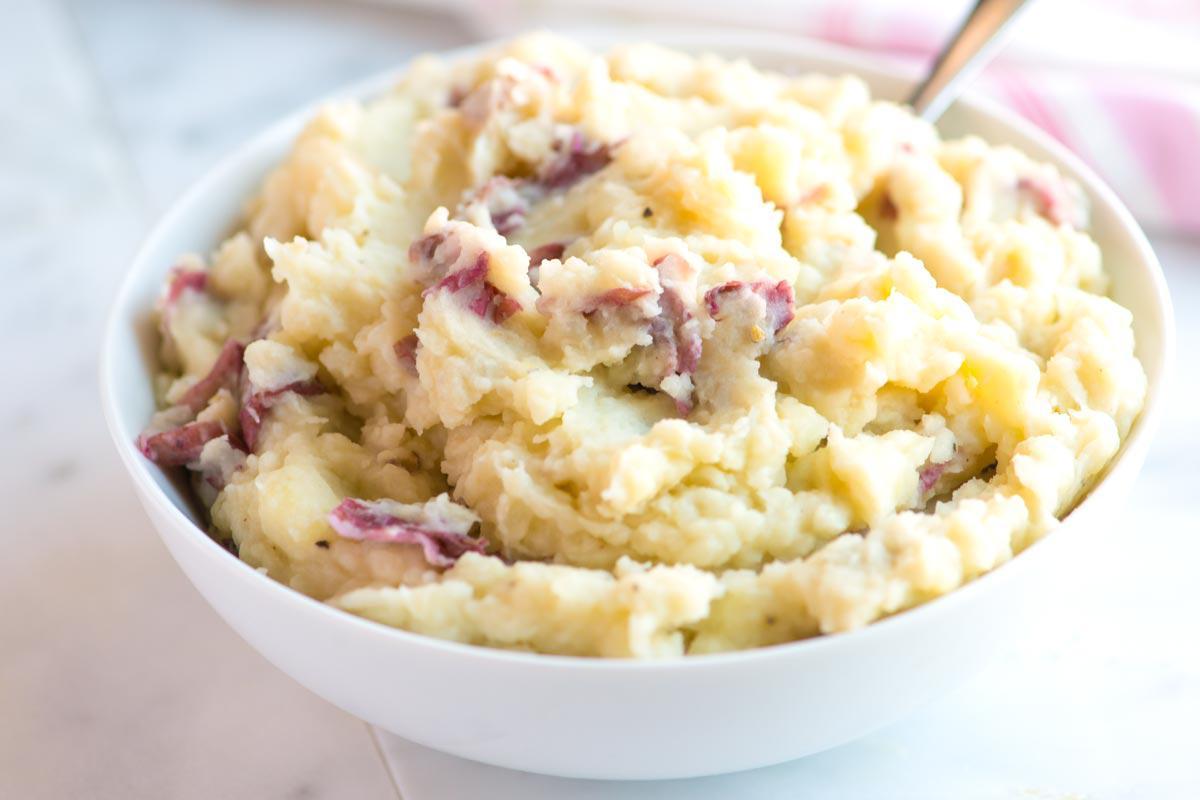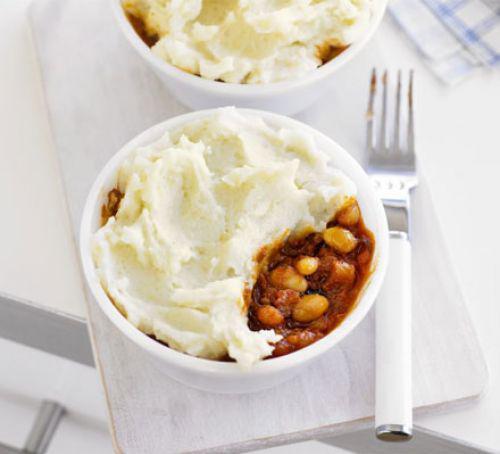The first image is the image on the left, the second image is the image on the right. For the images shown, is this caption "An item of silverware is on a napkin that also holds a round white dish containing mashed potatoes." true? Answer yes or no. Yes. The first image is the image on the left, the second image is the image on the right. Given the left and right images, does the statement "Silverware is shown near the bowl in one of the images." hold true? Answer yes or no. Yes. 